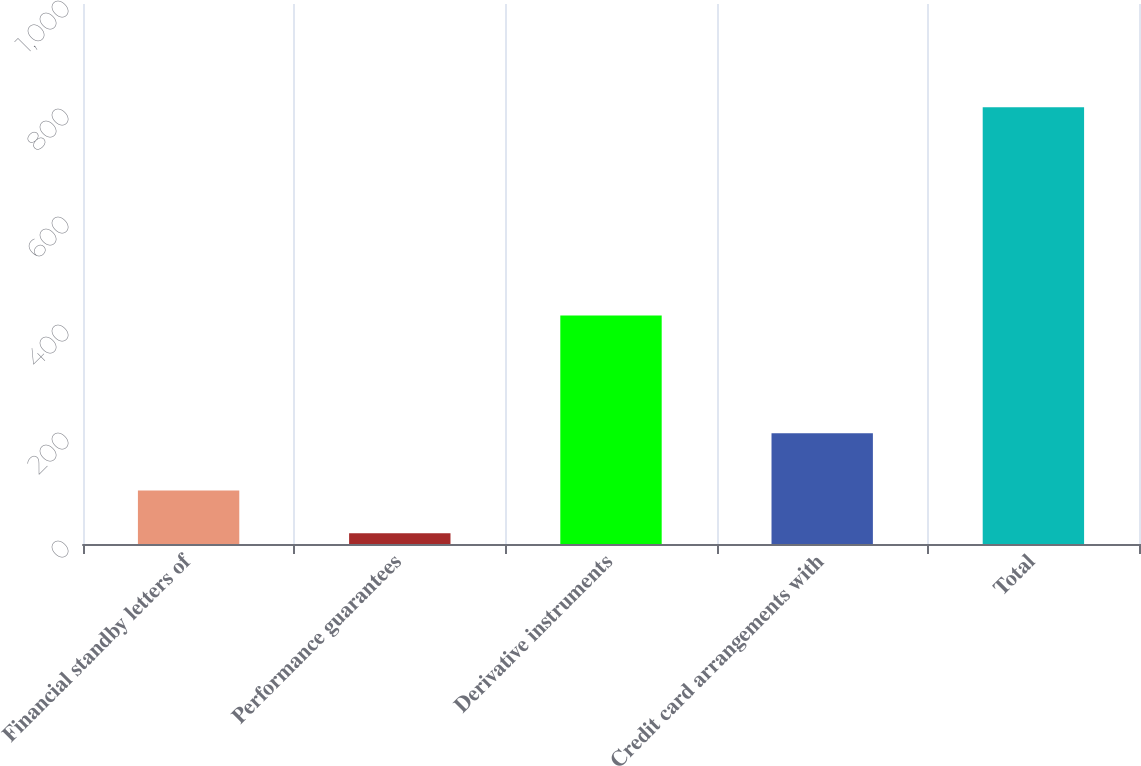Convert chart. <chart><loc_0><loc_0><loc_500><loc_500><bar_chart><fcel>Financial standby letters of<fcel>Performance guarantees<fcel>Derivative instruments<fcel>Credit card arrangements with<fcel>Total<nl><fcel>98.9<fcel>20<fcel>423<fcel>205<fcel>809<nl></chart> 